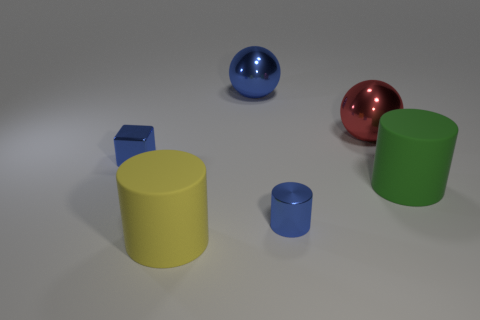Add 2 big brown metal blocks. How many objects exist? 8 Subtract all spheres. How many objects are left? 4 Add 5 red objects. How many red objects exist? 6 Subtract 0 yellow balls. How many objects are left? 6 Subtract all large rubber cylinders. Subtract all blue objects. How many objects are left? 1 Add 1 big green cylinders. How many big green cylinders are left? 2 